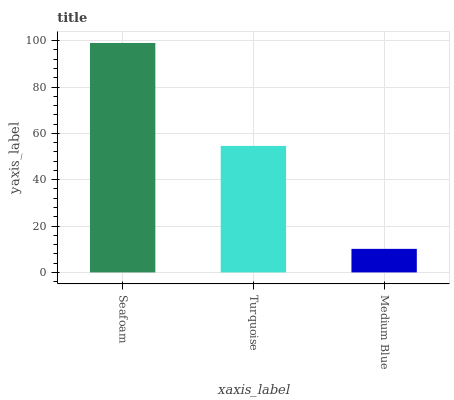Is Medium Blue the minimum?
Answer yes or no. Yes. Is Seafoam the maximum?
Answer yes or no. Yes. Is Turquoise the minimum?
Answer yes or no. No. Is Turquoise the maximum?
Answer yes or no. No. Is Seafoam greater than Turquoise?
Answer yes or no. Yes. Is Turquoise less than Seafoam?
Answer yes or no. Yes. Is Turquoise greater than Seafoam?
Answer yes or no. No. Is Seafoam less than Turquoise?
Answer yes or no. No. Is Turquoise the high median?
Answer yes or no. Yes. Is Turquoise the low median?
Answer yes or no. Yes. Is Medium Blue the high median?
Answer yes or no. No. Is Seafoam the low median?
Answer yes or no. No. 